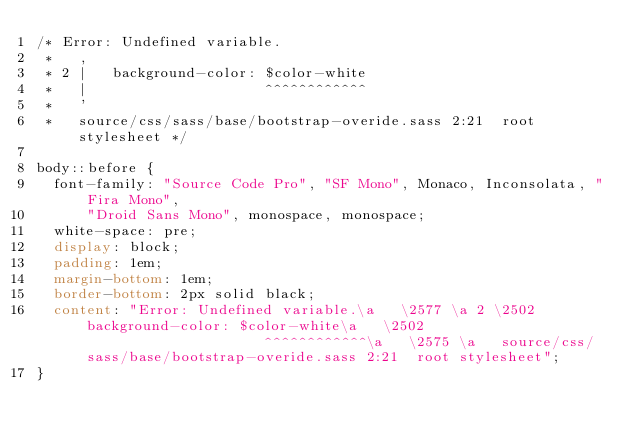Convert code to text. <code><loc_0><loc_0><loc_500><loc_500><_CSS_>/* Error: Undefined variable.
 *   ,
 * 2 |   background-color: $color-white
 *   |                     ^^^^^^^^^^^^
 *   '
 *   source/css/sass/base/bootstrap-overide.sass 2:21  root stylesheet */

body::before {
  font-family: "Source Code Pro", "SF Mono", Monaco, Inconsolata, "Fira Mono",
      "Droid Sans Mono", monospace, monospace;
  white-space: pre;
  display: block;
  padding: 1em;
  margin-bottom: 1em;
  border-bottom: 2px solid black;
  content: "Error: Undefined variable.\a   \2577 \a 2 \2502    background-color: $color-white\a   \2502                      ^^^^^^^^^^^^\a   \2575 \a   source/css/sass/base/bootstrap-overide.sass 2:21  root stylesheet";
}
</code> 